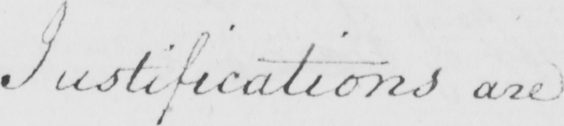Please provide the text content of this handwritten line. Justifications are 